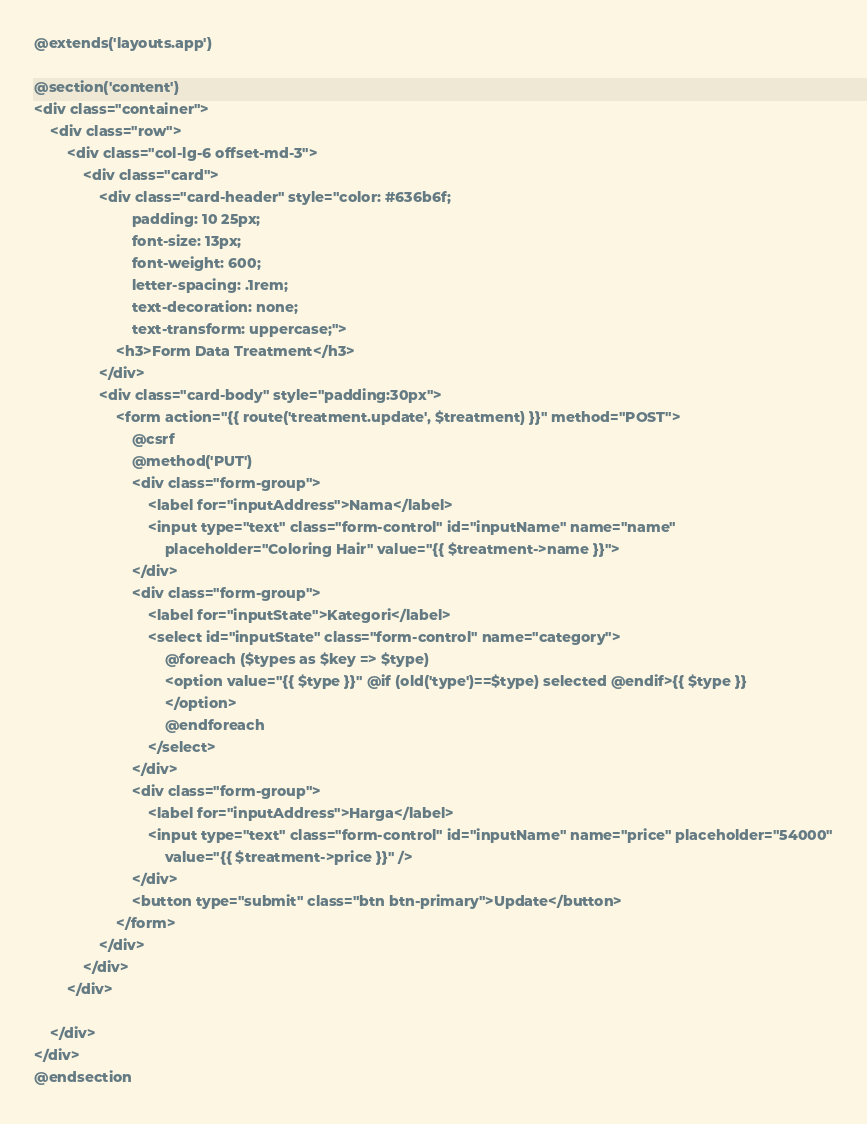<code> <loc_0><loc_0><loc_500><loc_500><_PHP_>@extends('layouts.app')

@section('content')
<div class="container">
    <div class="row">
        <div class="col-lg-6 offset-md-3">
            <div class="card">
                <div class="card-header" style="color: #636b6f;
                        padding: 10 25px;
                        font-size: 13px;
                        font-weight: 600;
                        letter-spacing: .1rem;
                        text-decoration: none;
                        text-transform: uppercase;">
                    <h3>Form Data Treatment</h3>
                </div>
                <div class="card-body" style="padding:30px">
                    <form action="{{ route('treatment.update', $treatment) }}" method="POST">
                        @csrf
                        @method('PUT')
                        <div class="form-group">
                            <label for="inputAddress">Nama</label>
                            <input type="text" class="form-control" id="inputName" name="name"
                                placeholder="Coloring Hair" value="{{ $treatment->name }}">
                        </div>
                        <div class="form-group">
                            <label for="inputState">Kategori</label>
                            <select id="inputState" class="form-control" name="category">
                                @foreach ($types as $key => $type)
                                <option value="{{ $type }}" @if (old('type')==$type) selected @endif>{{ $type }}
                                </option>
                                @endforeach
                            </select>
                        </div>
                        <div class="form-group">
                            <label for="inputAddress">Harga</label>
                            <input type="text" class="form-control" id="inputName" name="price" placeholder="54000"
                                value="{{ $treatment->price }}" />
                        </div>
                        <button type="submit" class="btn btn-primary">Update</button>
                    </form>
                </div>
            </div>
        </div>

    </div>
</div>
@endsection
</code> 